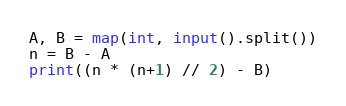<code> <loc_0><loc_0><loc_500><loc_500><_Python_>A, B = map(int, input().split())
n = B - A
print((n * (n+1) // 2) - B)</code> 